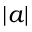Convert formula to latex. <formula><loc_0><loc_0><loc_500><loc_500>| a |</formula> 